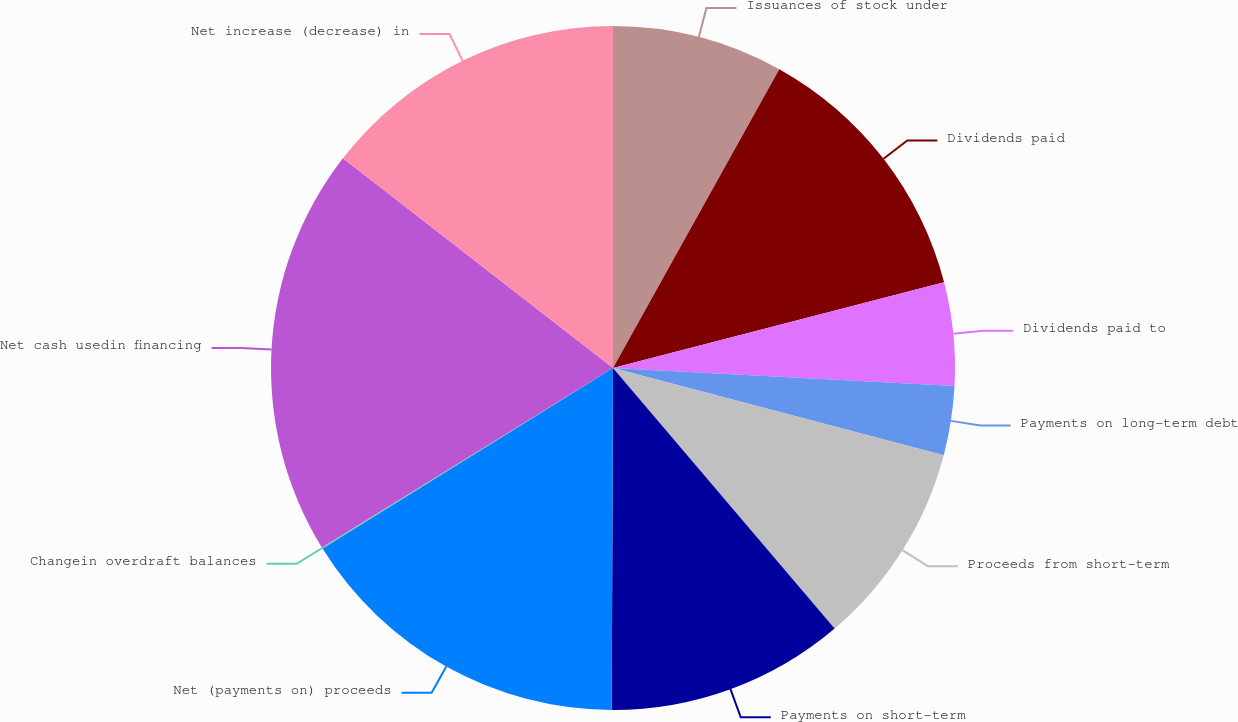Convert chart to OTSL. <chart><loc_0><loc_0><loc_500><loc_500><pie_chart><fcel>Issuances of stock under<fcel>Dividends paid<fcel>Dividends paid to<fcel>Payments on long-term debt<fcel>Proceeds from short-term<fcel>Payments on short-term<fcel>Net (payments on) proceeds<fcel>Changein overdraft balances<fcel>Net cash usedin financing<fcel>Net increase (decrease) in<nl><fcel>8.08%<fcel>12.89%<fcel>4.87%<fcel>3.26%<fcel>9.68%<fcel>11.28%<fcel>16.09%<fcel>0.06%<fcel>19.3%<fcel>14.49%<nl></chart> 